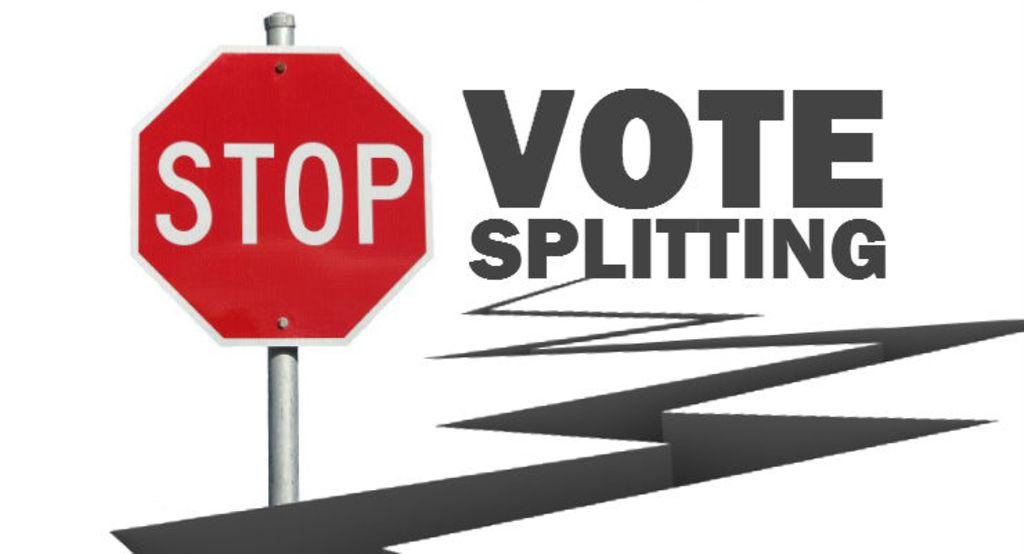Provide a one-sentence caption for the provided image. A Stop sign is in front of a zig zag line ending in the words Vote Splitting. 